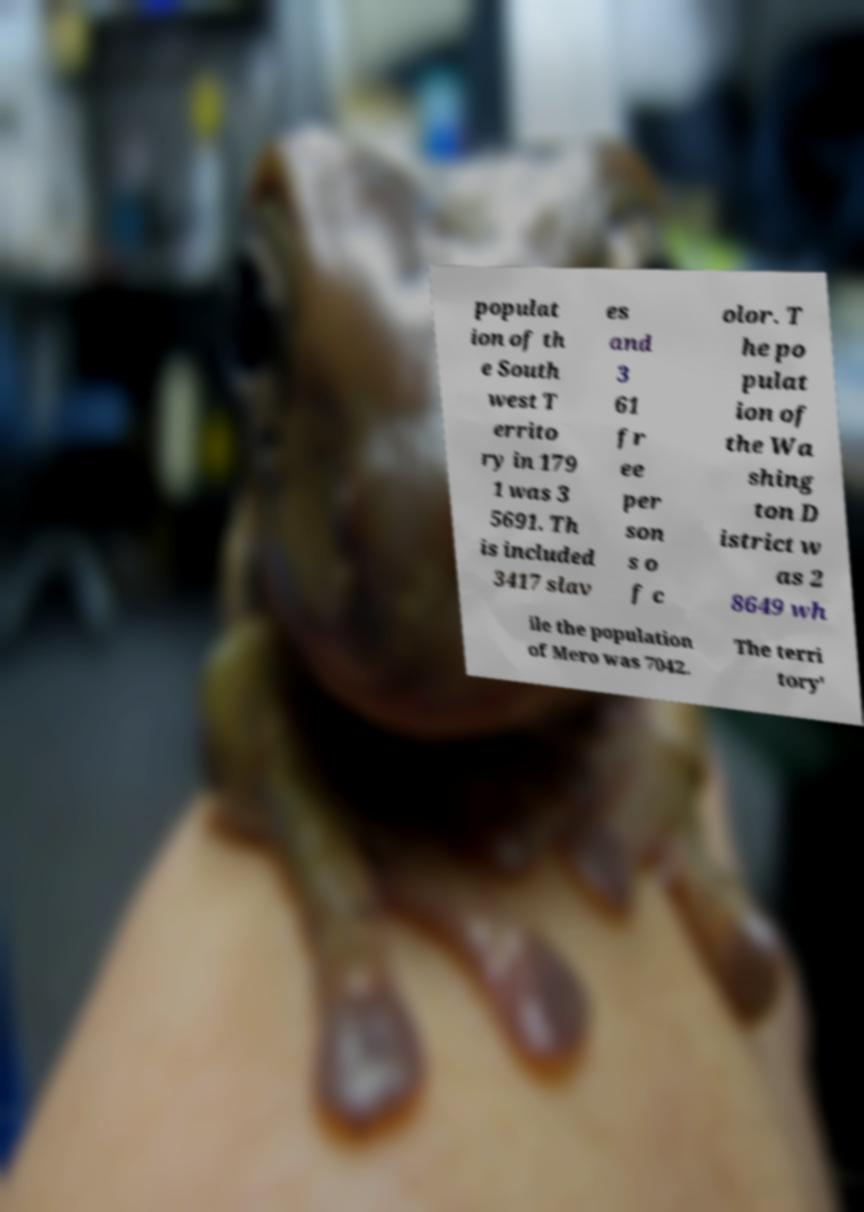Can you read and provide the text displayed in the image?This photo seems to have some interesting text. Can you extract and type it out for me? populat ion of th e South west T errito ry in 179 1 was 3 5691. Th is included 3417 slav es and 3 61 fr ee per son s o f c olor. T he po pulat ion of the Wa shing ton D istrict w as 2 8649 wh ile the population of Mero was 7042. The terri tory' 